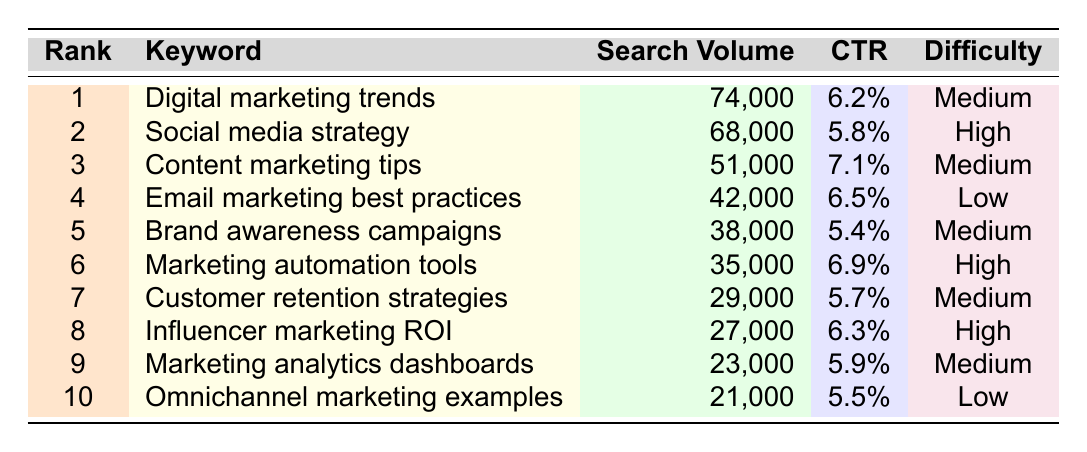What is the keyword with the highest search volume? The table shows the search volumes for each keyword. The highest value is 74,000 for the keyword "Digital marketing trends," which is the first row in the table.
Answer: Digital marketing trends How many keywords have a high difficulty rating? The table lists the difficulty ratings for each keyword. Keywords with a 'High' difficulty rating include "Social media strategy," "Marketing automation tools," and "Influencer marketing ROI," totaling three keywords.
Answer: 3 What is the average click-through rate (CTR) of the keywords listed? To find the average CTR, we take the individual CTR percentages (6.2, 5.8, 7.1, 6.5, 5.4, 6.9, 5.7, 6.3, 5.9, 5.5) and sum them (63.9) and then divide by the number of keywords (10). Therefore, the average CTR is 63.9 / 10 = 6.39%.
Answer: 6.39% Is there a keyword with a low difficulty rating that has a search volume over 40,000? By checking the table, we find that "Email marketing best practices" is the only keyword with a Low difficulty rating and a search volume (42,000) over 40,000. Hence, the statement is true.
Answer: Yes Which keyword has the lowest search volume, and what is its CTR? In the table, the keyword with the lowest search volume is "Omnichannel marketing examples," with a search volume of 21,000. The CTR corresponding to this keyword is 5.5%.
Answer: Omnichannel marketing examples, 5.5% 